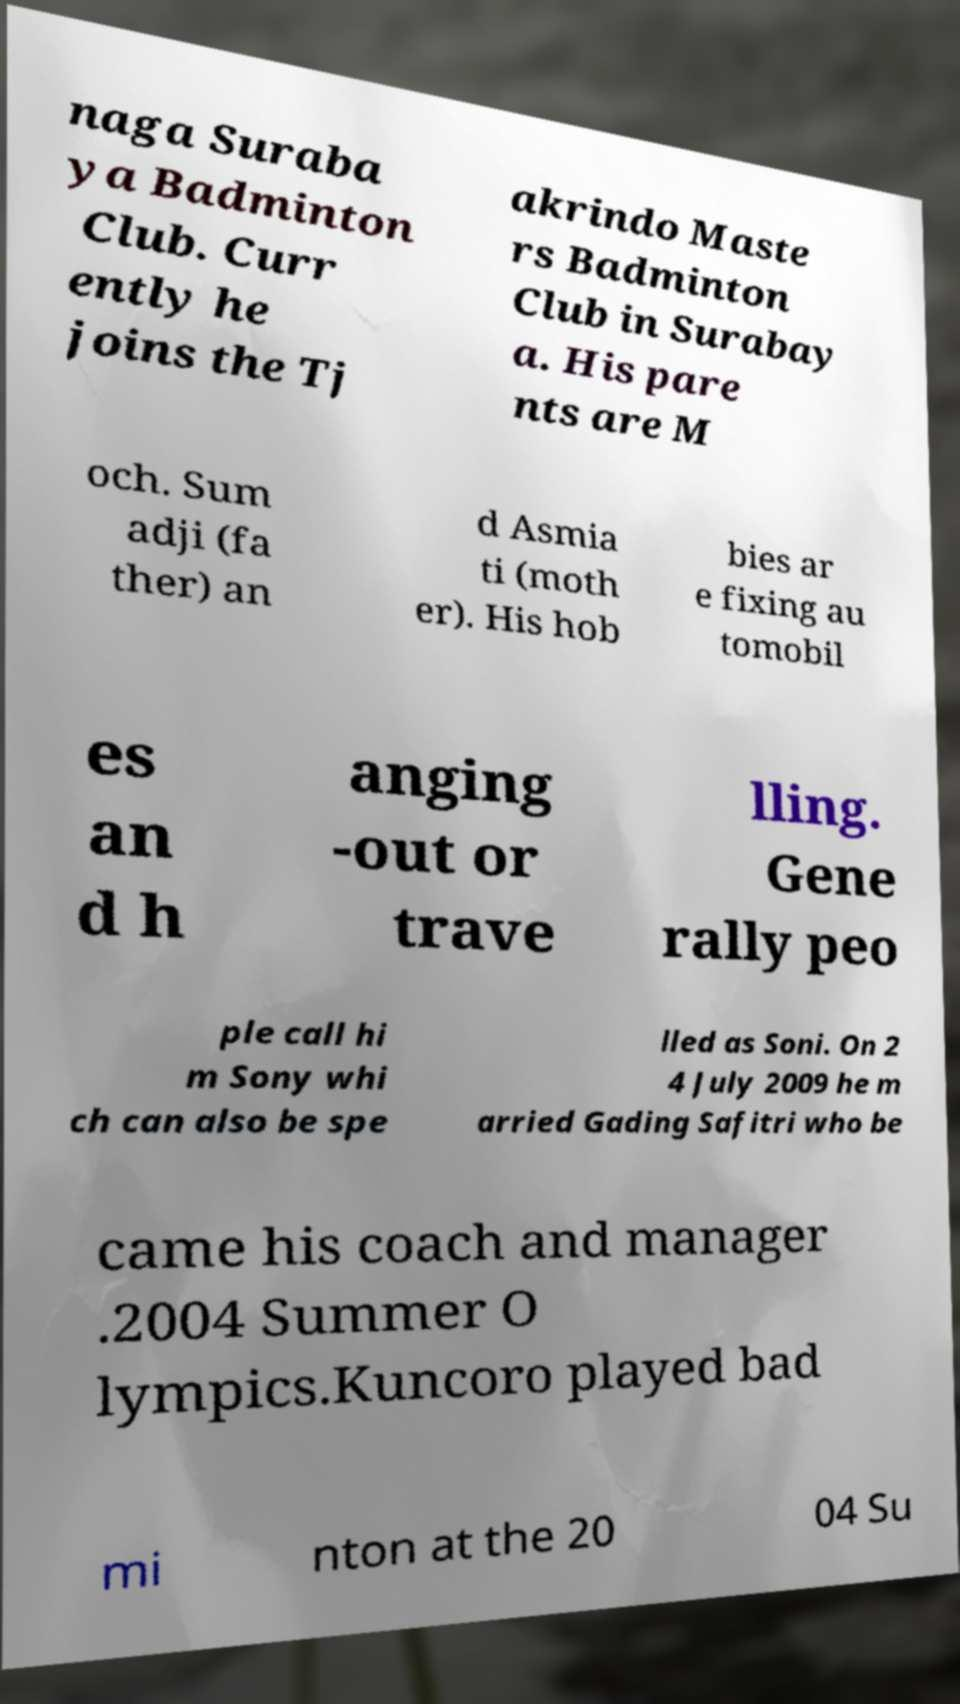Please identify and transcribe the text found in this image. naga Suraba ya Badminton Club. Curr ently he joins the Tj akrindo Maste rs Badminton Club in Surabay a. His pare nts are M och. Sum adji (fa ther) an d Asmia ti (moth er). His hob bies ar e fixing au tomobil es an d h anging -out or trave lling. Gene rally peo ple call hi m Sony whi ch can also be spe lled as Soni. On 2 4 July 2009 he m arried Gading Safitri who be came his coach and manager .2004 Summer O lympics.Kuncoro played bad mi nton at the 20 04 Su 